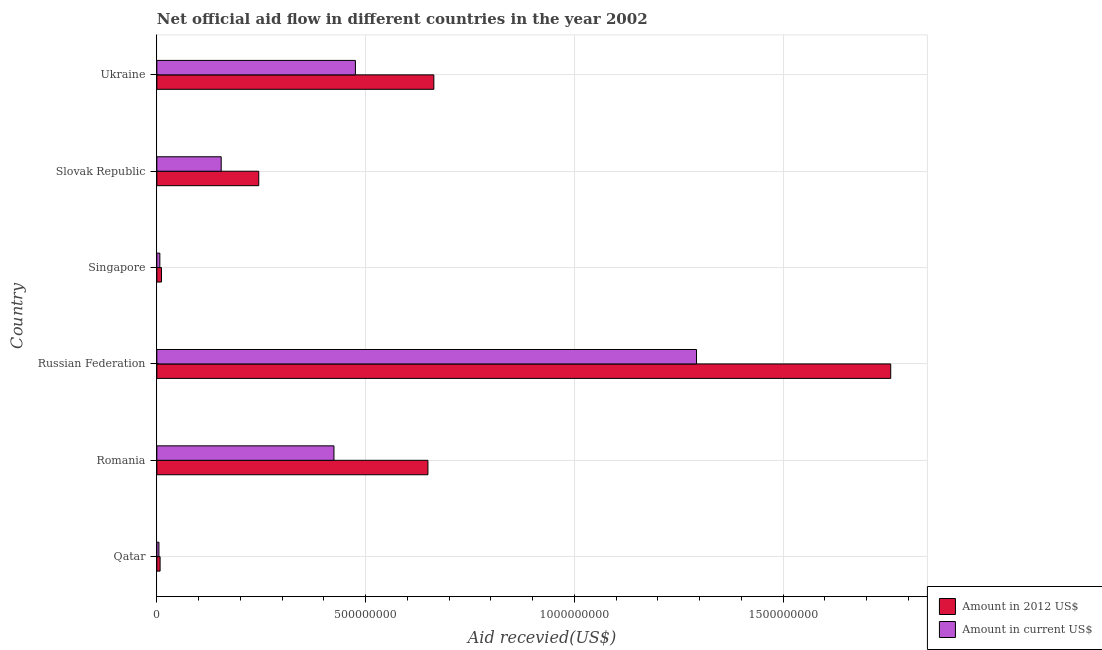How many groups of bars are there?
Provide a succinct answer. 6. How many bars are there on the 6th tick from the top?
Provide a succinct answer. 2. What is the label of the 5th group of bars from the top?
Provide a short and direct response. Romania. What is the amount of aid received(expressed in 2012 us$) in Singapore?
Provide a succinct answer. 1.11e+07. Across all countries, what is the maximum amount of aid received(expressed in us$)?
Make the answer very short. 1.29e+09. Across all countries, what is the minimum amount of aid received(expressed in 2012 us$)?
Your answer should be very brief. 7.79e+06. In which country was the amount of aid received(expressed in 2012 us$) maximum?
Provide a short and direct response. Russian Federation. In which country was the amount of aid received(expressed in 2012 us$) minimum?
Provide a succinct answer. Qatar. What is the total amount of aid received(expressed in us$) in the graph?
Offer a terse response. 2.36e+09. What is the difference between the amount of aid received(expressed in 2012 us$) in Romania and that in Singapore?
Make the answer very short. 6.38e+08. What is the difference between the amount of aid received(expressed in us$) in Russian Federation and the amount of aid received(expressed in 2012 us$) in Singapore?
Give a very brief answer. 1.28e+09. What is the average amount of aid received(expressed in 2012 us$) per country?
Your response must be concise. 5.56e+08. What is the difference between the amount of aid received(expressed in us$) and amount of aid received(expressed in 2012 us$) in Romania?
Your answer should be compact. -2.25e+08. In how many countries, is the amount of aid received(expressed in us$) greater than 900000000 US$?
Offer a terse response. 1. What is the ratio of the amount of aid received(expressed in 2012 us$) in Romania to that in Slovak Republic?
Provide a succinct answer. 2.66. Is the amount of aid received(expressed in 2012 us$) in Romania less than that in Ukraine?
Offer a terse response. Yes. What is the difference between the highest and the second highest amount of aid received(expressed in us$)?
Your response must be concise. 8.17e+08. What is the difference between the highest and the lowest amount of aid received(expressed in us$)?
Your answer should be compact. 1.29e+09. In how many countries, is the amount of aid received(expressed in 2012 us$) greater than the average amount of aid received(expressed in 2012 us$) taken over all countries?
Give a very brief answer. 3. What does the 2nd bar from the top in Romania represents?
Provide a short and direct response. Amount in 2012 US$. What does the 1st bar from the bottom in Slovak Republic represents?
Provide a succinct answer. Amount in 2012 US$. Are all the bars in the graph horizontal?
Provide a short and direct response. Yes. How many countries are there in the graph?
Make the answer very short. 6. What is the difference between two consecutive major ticks on the X-axis?
Make the answer very short. 5.00e+08. Are the values on the major ticks of X-axis written in scientific E-notation?
Ensure brevity in your answer.  No. Does the graph contain grids?
Ensure brevity in your answer.  Yes. How many legend labels are there?
Give a very brief answer. 2. How are the legend labels stacked?
Your answer should be compact. Vertical. What is the title of the graph?
Offer a very short reply. Net official aid flow in different countries in the year 2002. What is the label or title of the X-axis?
Your response must be concise. Aid recevied(US$). What is the label or title of the Y-axis?
Offer a very short reply. Country. What is the Aid recevied(US$) in Amount in 2012 US$ in Qatar?
Offer a terse response. 7.79e+06. What is the Aid recevied(US$) in Amount in current US$ in Qatar?
Make the answer very short. 5.02e+06. What is the Aid recevied(US$) of Amount in 2012 US$ in Romania?
Your response must be concise. 6.49e+08. What is the Aid recevied(US$) of Amount in current US$ in Romania?
Give a very brief answer. 4.24e+08. What is the Aid recevied(US$) of Amount in 2012 US$ in Russian Federation?
Provide a short and direct response. 1.76e+09. What is the Aid recevied(US$) of Amount in current US$ in Russian Federation?
Your answer should be compact. 1.29e+09. What is the Aid recevied(US$) of Amount in 2012 US$ in Singapore?
Make the answer very short. 1.11e+07. What is the Aid recevied(US$) in Amount in current US$ in Singapore?
Your response must be concise. 7.19e+06. What is the Aid recevied(US$) of Amount in 2012 US$ in Slovak Republic?
Give a very brief answer. 2.44e+08. What is the Aid recevied(US$) in Amount in current US$ in Slovak Republic?
Your answer should be very brief. 1.54e+08. What is the Aid recevied(US$) of Amount in 2012 US$ in Ukraine?
Ensure brevity in your answer.  6.63e+08. What is the Aid recevied(US$) of Amount in current US$ in Ukraine?
Ensure brevity in your answer.  4.76e+08. Across all countries, what is the maximum Aid recevied(US$) in Amount in 2012 US$?
Provide a succinct answer. 1.76e+09. Across all countries, what is the maximum Aid recevied(US$) of Amount in current US$?
Offer a terse response. 1.29e+09. Across all countries, what is the minimum Aid recevied(US$) in Amount in 2012 US$?
Provide a short and direct response. 7.79e+06. Across all countries, what is the minimum Aid recevied(US$) in Amount in current US$?
Give a very brief answer. 5.02e+06. What is the total Aid recevied(US$) in Amount in 2012 US$ in the graph?
Provide a succinct answer. 3.33e+09. What is the total Aid recevied(US$) in Amount in current US$ in the graph?
Your answer should be compact. 2.36e+09. What is the difference between the Aid recevied(US$) of Amount in 2012 US$ in Qatar and that in Romania?
Your answer should be compact. -6.41e+08. What is the difference between the Aid recevied(US$) of Amount in current US$ in Qatar and that in Romania?
Give a very brief answer. -4.19e+08. What is the difference between the Aid recevied(US$) in Amount in 2012 US$ in Qatar and that in Russian Federation?
Give a very brief answer. -1.75e+09. What is the difference between the Aid recevied(US$) in Amount in current US$ in Qatar and that in Russian Federation?
Your answer should be very brief. -1.29e+09. What is the difference between the Aid recevied(US$) of Amount in 2012 US$ in Qatar and that in Singapore?
Give a very brief answer. -3.28e+06. What is the difference between the Aid recevied(US$) of Amount in current US$ in Qatar and that in Singapore?
Provide a short and direct response. -2.17e+06. What is the difference between the Aid recevied(US$) of Amount in 2012 US$ in Qatar and that in Slovak Republic?
Make the answer very short. -2.36e+08. What is the difference between the Aid recevied(US$) in Amount in current US$ in Qatar and that in Slovak Republic?
Your answer should be compact. -1.49e+08. What is the difference between the Aid recevied(US$) of Amount in 2012 US$ in Qatar and that in Ukraine?
Ensure brevity in your answer.  -6.56e+08. What is the difference between the Aid recevied(US$) of Amount in current US$ in Qatar and that in Ukraine?
Your response must be concise. -4.71e+08. What is the difference between the Aid recevied(US$) of Amount in 2012 US$ in Romania and that in Russian Federation?
Offer a terse response. -1.11e+09. What is the difference between the Aid recevied(US$) of Amount in current US$ in Romania and that in Russian Federation?
Your response must be concise. -8.68e+08. What is the difference between the Aid recevied(US$) in Amount in 2012 US$ in Romania and that in Singapore?
Give a very brief answer. 6.38e+08. What is the difference between the Aid recevied(US$) of Amount in current US$ in Romania and that in Singapore?
Make the answer very short. 4.17e+08. What is the difference between the Aid recevied(US$) of Amount in 2012 US$ in Romania and that in Slovak Republic?
Provide a succinct answer. 4.05e+08. What is the difference between the Aid recevied(US$) of Amount in current US$ in Romania and that in Slovak Republic?
Your answer should be very brief. 2.70e+08. What is the difference between the Aid recevied(US$) of Amount in 2012 US$ in Romania and that in Ukraine?
Your answer should be compact. -1.42e+07. What is the difference between the Aid recevied(US$) in Amount in current US$ in Romania and that in Ukraine?
Keep it short and to the point. -5.14e+07. What is the difference between the Aid recevied(US$) of Amount in 2012 US$ in Russian Federation and that in Singapore?
Your answer should be very brief. 1.75e+09. What is the difference between the Aid recevied(US$) of Amount in current US$ in Russian Federation and that in Singapore?
Ensure brevity in your answer.  1.29e+09. What is the difference between the Aid recevied(US$) in Amount in 2012 US$ in Russian Federation and that in Slovak Republic?
Ensure brevity in your answer.  1.51e+09. What is the difference between the Aid recevied(US$) in Amount in current US$ in Russian Federation and that in Slovak Republic?
Ensure brevity in your answer.  1.14e+09. What is the difference between the Aid recevied(US$) in Amount in 2012 US$ in Russian Federation and that in Ukraine?
Offer a terse response. 1.09e+09. What is the difference between the Aid recevied(US$) of Amount in current US$ in Russian Federation and that in Ukraine?
Provide a succinct answer. 8.17e+08. What is the difference between the Aid recevied(US$) of Amount in 2012 US$ in Singapore and that in Slovak Republic?
Make the answer very short. -2.33e+08. What is the difference between the Aid recevied(US$) in Amount in current US$ in Singapore and that in Slovak Republic?
Your answer should be very brief. -1.47e+08. What is the difference between the Aid recevied(US$) of Amount in 2012 US$ in Singapore and that in Ukraine?
Keep it short and to the point. -6.52e+08. What is the difference between the Aid recevied(US$) in Amount in current US$ in Singapore and that in Ukraine?
Offer a very short reply. -4.68e+08. What is the difference between the Aid recevied(US$) in Amount in 2012 US$ in Slovak Republic and that in Ukraine?
Your response must be concise. -4.19e+08. What is the difference between the Aid recevied(US$) in Amount in current US$ in Slovak Republic and that in Ukraine?
Keep it short and to the point. -3.21e+08. What is the difference between the Aid recevied(US$) of Amount in 2012 US$ in Qatar and the Aid recevied(US$) of Amount in current US$ in Romania?
Your response must be concise. -4.16e+08. What is the difference between the Aid recevied(US$) in Amount in 2012 US$ in Qatar and the Aid recevied(US$) in Amount in current US$ in Russian Federation?
Provide a short and direct response. -1.28e+09. What is the difference between the Aid recevied(US$) of Amount in 2012 US$ in Qatar and the Aid recevied(US$) of Amount in current US$ in Singapore?
Give a very brief answer. 6.00e+05. What is the difference between the Aid recevied(US$) of Amount in 2012 US$ in Qatar and the Aid recevied(US$) of Amount in current US$ in Slovak Republic?
Provide a succinct answer. -1.46e+08. What is the difference between the Aid recevied(US$) in Amount in 2012 US$ in Qatar and the Aid recevied(US$) in Amount in current US$ in Ukraine?
Ensure brevity in your answer.  -4.68e+08. What is the difference between the Aid recevied(US$) of Amount in 2012 US$ in Romania and the Aid recevied(US$) of Amount in current US$ in Russian Federation?
Ensure brevity in your answer.  -6.43e+08. What is the difference between the Aid recevied(US$) in Amount in 2012 US$ in Romania and the Aid recevied(US$) in Amount in current US$ in Singapore?
Provide a succinct answer. 6.42e+08. What is the difference between the Aid recevied(US$) of Amount in 2012 US$ in Romania and the Aid recevied(US$) of Amount in current US$ in Slovak Republic?
Your response must be concise. 4.95e+08. What is the difference between the Aid recevied(US$) of Amount in 2012 US$ in Romania and the Aid recevied(US$) of Amount in current US$ in Ukraine?
Keep it short and to the point. 1.74e+08. What is the difference between the Aid recevied(US$) of Amount in 2012 US$ in Russian Federation and the Aid recevied(US$) of Amount in current US$ in Singapore?
Ensure brevity in your answer.  1.75e+09. What is the difference between the Aid recevied(US$) in Amount in 2012 US$ in Russian Federation and the Aid recevied(US$) in Amount in current US$ in Slovak Republic?
Offer a terse response. 1.60e+09. What is the difference between the Aid recevied(US$) of Amount in 2012 US$ in Russian Federation and the Aid recevied(US$) of Amount in current US$ in Ukraine?
Provide a short and direct response. 1.28e+09. What is the difference between the Aid recevied(US$) of Amount in 2012 US$ in Singapore and the Aid recevied(US$) of Amount in current US$ in Slovak Republic?
Your answer should be very brief. -1.43e+08. What is the difference between the Aid recevied(US$) of Amount in 2012 US$ in Singapore and the Aid recevied(US$) of Amount in current US$ in Ukraine?
Provide a succinct answer. -4.64e+08. What is the difference between the Aid recevied(US$) of Amount in 2012 US$ in Slovak Republic and the Aid recevied(US$) of Amount in current US$ in Ukraine?
Make the answer very short. -2.31e+08. What is the average Aid recevied(US$) in Amount in 2012 US$ per country?
Offer a very short reply. 5.56e+08. What is the average Aid recevied(US$) in Amount in current US$ per country?
Offer a terse response. 3.93e+08. What is the difference between the Aid recevied(US$) of Amount in 2012 US$ and Aid recevied(US$) of Amount in current US$ in Qatar?
Provide a succinct answer. 2.77e+06. What is the difference between the Aid recevied(US$) of Amount in 2012 US$ and Aid recevied(US$) of Amount in current US$ in Romania?
Provide a short and direct response. 2.25e+08. What is the difference between the Aid recevied(US$) in Amount in 2012 US$ and Aid recevied(US$) in Amount in current US$ in Russian Federation?
Your answer should be compact. 4.65e+08. What is the difference between the Aid recevied(US$) of Amount in 2012 US$ and Aid recevied(US$) of Amount in current US$ in Singapore?
Provide a short and direct response. 3.88e+06. What is the difference between the Aid recevied(US$) in Amount in 2012 US$ and Aid recevied(US$) in Amount in current US$ in Slovak Republic?
Keep it short and to the point. 8.99e+07. What is the difference between the Aid recevied(US$) of Amount in 2012 US$ and Aid recevied(US$) of Amount in current US$ in Ukraine?
Keep it short and to the point. 1.88e+08. What is the ratio of the Aid recevied(US$) in Amount in 2012 US$ in Qatar to that in Romania?
Your answer should be very brief. 0.01. What is the ratio of the Aid recevied(US$) of Amount in current US$ in Qatar to that in Romania?
Make the answer very short. 0.01. What is the ratio of the Aid recevied(US$) of Amount in 2012 US$ in Qatar to that in Russian Federation?
Your answer should be very brief. 0. What is the ratio of the Aid recevied(US$) in Amount in current US$ in Qatar to that in Russian Federation?
Your response must be concise. 0. What is the ratio of the Aid recevied(US$) in Amount in 2012 US$ in Qatar to that in Singapore?
Your answer should be very brief. 0.7. What is the ratio of the Aid recevied(US$) of Amount in current US$ in Qatar to that in Singapore?
Provide a succinct answer. 0.7. What is the ratio of the Aid recevied(US$) in Amount in 2012 US$ in Qatar to that in Slovak Republic?
Make the answer very short. 0.03. What is the ratio of the Aid recevied(US$) in Amount in current US$ in Qatar to that in Slovak Republic?
Make the answer very short. 0.03. What is the ratio of the Aid recevied(US$) in Amount in 2012 US$ in Qatar to that in Ukraine?
Provide a short and direct response. 0.01. What is the ratio of the Aid recevied(US$) in Amount in current US$ in Qatar to that in Ukraine?
Ensure brevity in your answer.  0.01. What is the ratio of the Aid recevied(US$) of Amount in 2012 US$ in Romania to that in Russian Federation?
Offer a terse response. 0.37. What is the ratio of the Aid recevied(US$) in Amount in current US$ in Romania to that in Russian Federation?
Your response must be concise. 0.33. What is the ratio of the Aid recevied(US$) of Amount in 2012 US$ in Romania to that in Singapore?
Your response must be concise. 58.65. What is the ratio of the Aid recevied(US$) in Amount in current US$ in Romania to that in Singapore?
Keep it short and to the point. 58.99. What is the ratio of the Aid recevied(US$) in Amount in 2012 US$ in Romania to that in Slovak Republic?
Offer a very short reply. 2.66. What is the ratio of the Aid recevied(US$) of Amount in current US$ in Romania to that in Slovak Republic?
Your response must be concise. 2.75. What is the ratio of the Aid recevied(US$) of Amount in 2012 US$ in Romania to that in Ukraine?
Ensure brevity in your answer.  0.98. What is the ratio of the Aid recevied(US$) of Amount in current US$ in Romania to that in Ukraine?
Your answer should be compact. 0.89. What is the ratio of the Aid recevied(US$) of Amount in 2012 US$ in Russian Federation to that in Singapore?
Provide a succinct answer. 158.77. What is the ratio of the Aid recevied(US$) in Amount in current US$ in Russian Federation to that in Singapore?
Offer a very short reply. 179.76. What is the ratio of the Aid recevied(US$) in Amount in 2012 US$ in Russian Federation to that in Slovak Republic?
Your answer should be compact. 7.2. What is the ratio of the Aid recevied(US$) of Amount in current US$ in Russian Federation to that in Slovak Republic?
Ensure brevity in your answer.  8.39. What is the ratio of the Aid recevied(US$) in Amount in 2012 US$ in Russian Federation to that in Ukraine?
Give a very brief answer. 2.65. What is the ratio of the Aid recevied(US$) of Amount in current US$ in Russian Federation to that in Ukraine?
Your answer should be very brief. 2.72. What is the ratio of the Aid recevied(US$) of Amount in 2012 US$ in Singapore to that in Slovak Republic?
Ensure brevity in your answer.  0.05. What is the ratio of the Aid recevied(US$) of Amount in current US$ in Singapore to that in Slovak Republic?
Make the answer very short. 0.05. What is the ratio of the Aid recevied(US$) of Amount in 2012 US$ in Singapore to that in Ukraine?
Ensure brevity in your answer.  0.02. What is the ratio of the Aid recevied(US$) in Amount in current US$ in Singapore to that in Ukraine?
Offer a very short reply. 0.02. What is the ratio of the Aid recevied(US$) of Amount in 2012 US$ in Slovak Republic to that in Ukraine?
Your response must be concise. 0.37. What is the ratio of the Aid recevied(US$) of Amount in current US$ in Slovak Republic to that in Ukraine?
Keep it short and to the point. 0.32. What is the difference between the highest and the second highest Aid recevied(US$) in Amount in 2012 US$?
Your answer should be very brief. 1.09e+09. What is the difference between the highest and the second highest Aid recevied(US$) in Amount in current US$?
Make the answer very short. 8.17e+08. What is the difference between the highest and the lowest Aid recevied(US$) of Amount in 2012 US$?
Your answer should be very brief. 1.75e+09. What is the difference between the highest and the lowest Aid recevied(US$) of Amount in current US$?
Give a very brief answer. 1.29e+09. 